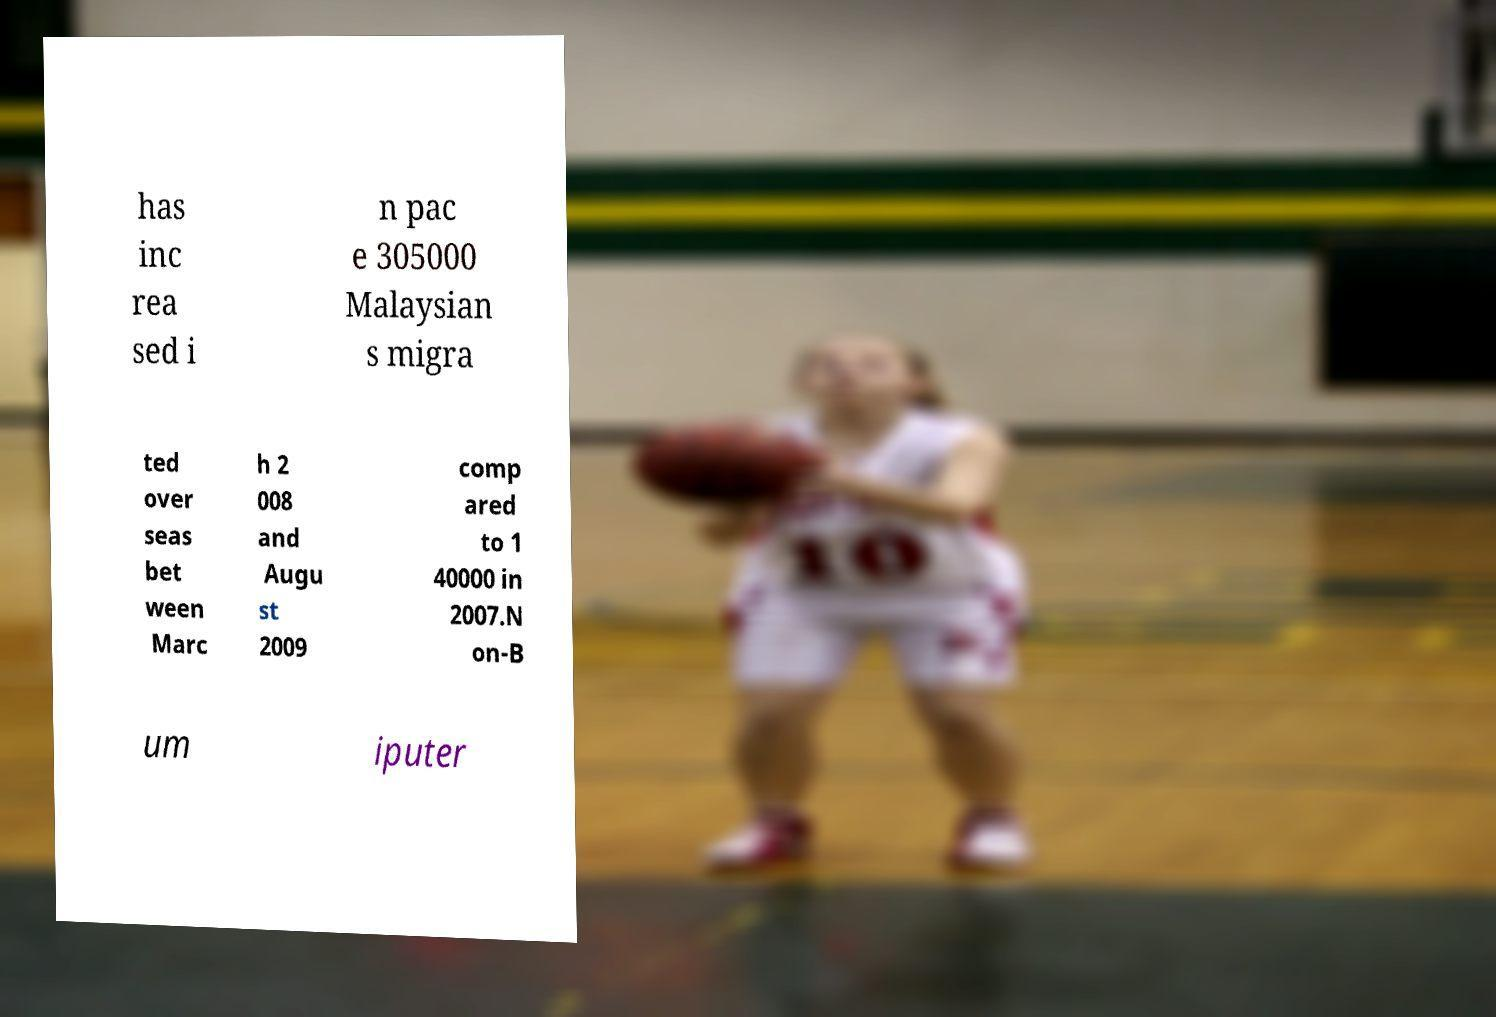For documentation purposes, I need the text within this image transcribed. Could you provide that? has inc rea sed i n pac e 305000 Malaysian s migra ted over seas bet ween Marc h 2 008 and Augu st 2009 comp ared to 1 40000 in 2007.N on-B um iputer 